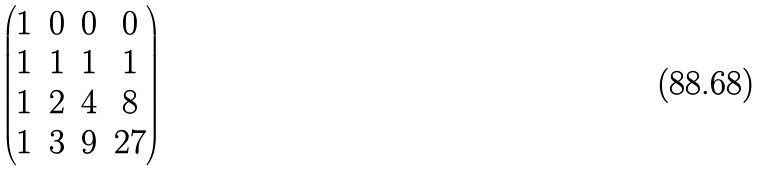Convert formula to latex. <formula><loc_0><loc_0><loc_500><loc_500>\begin{pmatrix} 1 & 0 & 0 & 0 \\ 1 & 1 & 1 & 1 \\ 1 & 2 & 4 & 8 \\ 1 & 3 & 9 & 2 7 \end{pmatrix}</formula> 